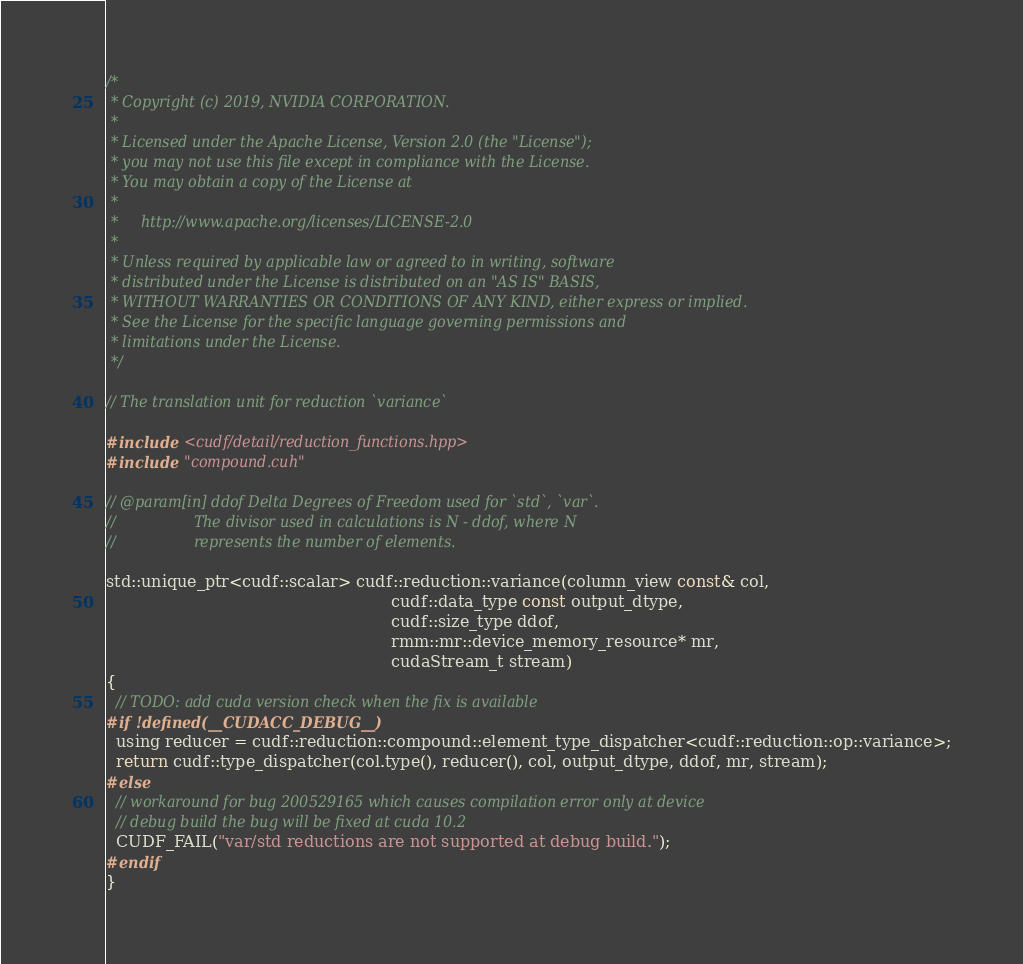Convert code to text. <code><loc_0><loc_0><loc_500><loc_500><_Cuda_>/*
 * Copyright (c) 2019, NVIDIA CORPORATION.
 *
 * Licensed under the Apache License, Version 2.0 (the "License");
 * you may not use this file except in compliance with the License.
 * You may obtain a copy of the License at
 *
 *     http://www.apache.org/licenses/LICENSE-2.0
 *
 * Unless required by applicable law or agreed to in writing, software
 * distributed under the License is distributed on an "AS IS" BASIS,
 * WITHOUT WARRANTIES OR CONDITIONS OF ANY KIND, either express or implied.
 * See the License for the specific language governing permissions and
 * limitations under the License.
 */

// The translation unit for reduction `variance`

#include <cudf/detail/reduction_functions.hpp>
#include "compound.cuh"

// @param[in] ddof Delta Degrees of Freedom used for `std`, `var`.
//                 The divisor used in calculations is N - ddof, where N
//                 represents the number of elements.

std::unique_ptr<cudf::scalar> cudf::reduction::variance(column_view const& col,
                                                        cudf::data_type const output_dtype,
                                                        cudf::size_type ddof,
                                                        rmm::mr::device_memory_resource* mr,
                                                        cudaStream_t stream)
{
  // TODO: add cuda version check when the fix is available
#if !defined(__CUDACC_DEBUG__)
  using reducer = cudf::reduction::compound::element_type_dispatcher<cudf::reduction::op::variance>;
  return cudf::type_dispatcher(col.type(), reducer(), col, output_dtype, ddof, mr, stream);
#else
  // workaround for bug 200529165 which causes compilation error only at device
  // debug build the bug will be fixed at cuda 10.2
  CUDF_FAIL("var/std reductions are not supported at debug build.");
#endif
}
</code> 